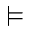<formula> <loc_0><loc_0><loc_500><loc_500>\vDash</formula> 